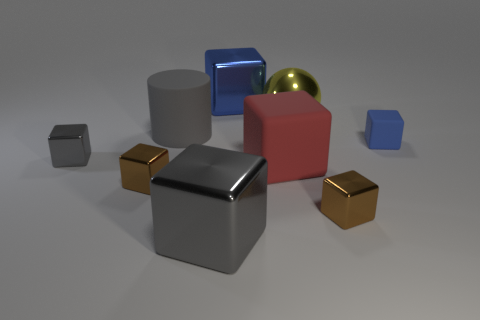Subtract 2 blocks. How many blocks are left? 5 Subtract all brown blocks. How many blocks are left? 5 Subtract all red rubber cubes. How many cubes are left? 6 Subtract all cyan spheres. Subtract all brown cylinders. How many spheres are left? 1 Subtract all cubes. How many objects are left? 2 Subtract all big red matte things. Subtract all brown objects. How many objects are left? 6 Add 8 small rubber cubes. How many small rubber cubes are left? 9 Add 7 yellow metal things. How many yellow metal things exist? 8 Subtract 0 red cylinders. How many objects are left? 9 